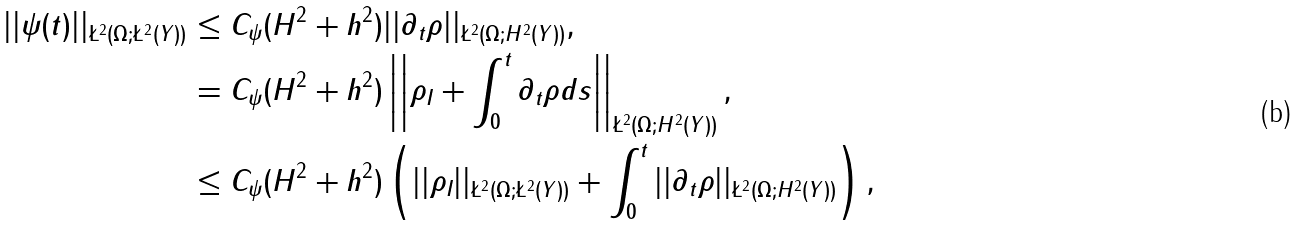<formula> <loc_0><loc_0><loc_500><loc_500>| | \psi ( t ) | | _ { \L ^ { 2 } ( \Omega ; \L ^ { 2 } ( Y ) ) } & \leq C _ { \psi } ( H ^ { 2 } + h ^ { 2 } ) | | \partial _ { t } \rho | | _ { \L ^ { 2 } ( \Omega ; H ^ { 2 } ( Y ) ) } , \\ & = C _ { \psi } ( H ^ { 2 } + h ^ { 2 } ) \left | \left | \rho _ { I } + \int _ { 0 } ^ { t } \partial _ { t } \rho d s \right | \right | _ { \L ^ { 2 } ( \Omega ; H ^ { 2 } ( Y ) ) } , \\ & \leq C _ { \psi } ( H ^ { 2 } + h ^ { 2 } ) \left ( | | \rho _ { I } | | _ { \L ^ { 2 } ( \Omega ; \L ^ { 2 } ( Y ) ) } + \int _ { 0 } ^ { t } | | \partial _ { t } \rho | | _ { \L ^ { 2 } ( \Omega ; H ^ { 2 } ( Y ) ) } \right ) ,</formula> 